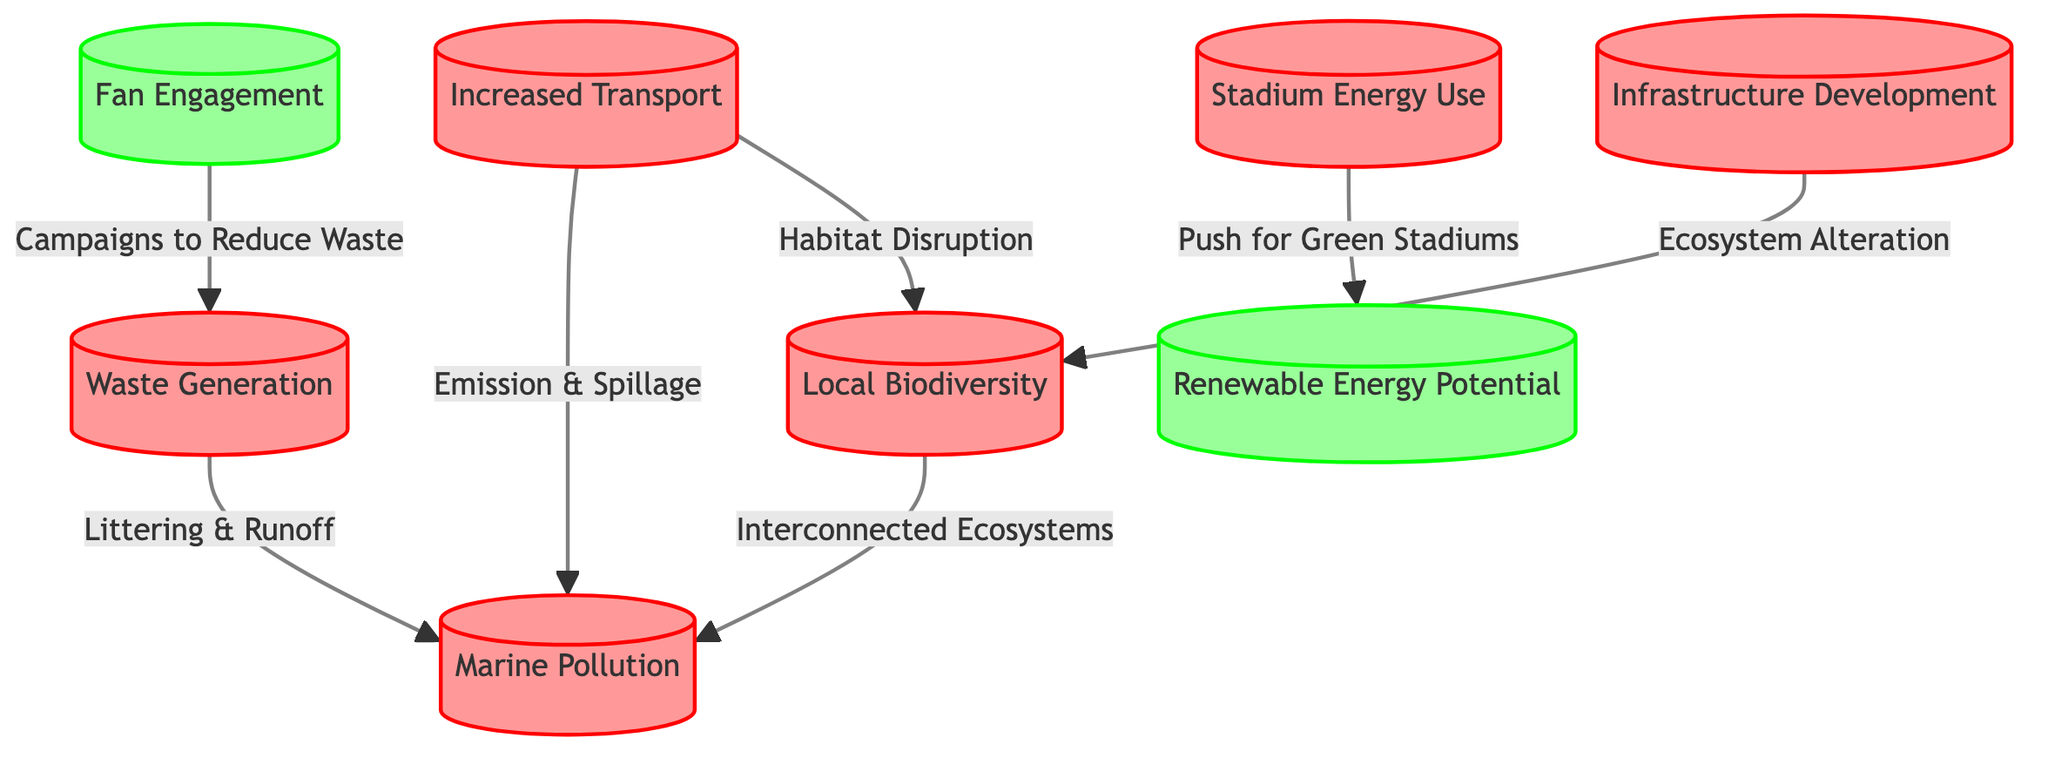What are the impacts associated with waste generation? The waste generation node is connected to marine pollution through the relationship "Littering & Runoff." This indicates that waste generation contributes to marine pollution.
Answer: Marine Pollution How many potential nodes are in the diagram? There are two nodes classified under potential: renewable energy potential and fan engagement.
Answer: 2 Which two nodes are impacted by increased transport? Increased transport connects to marine pollution through "Emission & Spillage," and to local biodiversity through "Habitat Disruption.” Therefore, the two nodes impacted by increased transport are marine pollution and local biodiversity.
Answer: Marine Pollution, Local Biodiversity What effect does stadium energy use have? The stadium energy use node is connected to the renewable energy potential node through the relationship "Push for Green Stadiums," indicating that it encourages renewable energy potential.
Answer: Renewable Energy Potential Which node represents the effect of infrastructure development? Infrastructure development connects directly to local biodiversity through "Ecosystem Alteration," indicating its effect.
Answer: Local Biodiversity How does fan engagement impact waste generation? Fan engagement is linked to waste generation with the relationship "Campaigns to Reduce Waste," suggesting that fan engagement efforts can help in reducing waste generation.
Answer: Waste Generation What are the two nodes connected to local biodiversity? Local biodiversity has connections from increased transport ("Habitat Disruption") and infrastructure development ("Ecosystem Alteration"). Thus, the two nodes connected to local biodiversity are increased transport and infrastructure development.
Answer: Increased Transport, Infrastructure Development What is the relationship between renewable energy potential and stadium energy use? Renewable energy potential is directly connected to stadium energy use through "Push for Green Stadiums," showing that stadium energy use promotes the development of renewable energy potential.
Answer: Push for Green Stadiums 